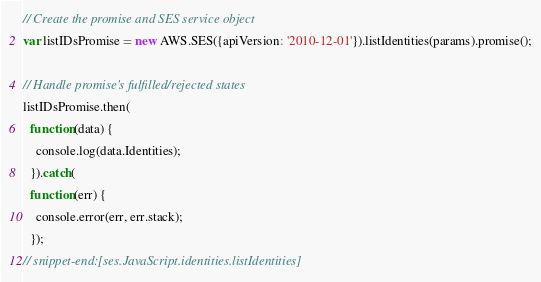<code> <loc_0><loc_0><loc_500><loc_500><_JavaScript_>
// Create the promise and SES service object
var listIDsPromise = new AWS.SES({apiVersion: '2010-12-01'}).listIdentities(params).promise();

// Handle promise's fulfilled/rejected states
listIDsPromise.then(
  function(data) {
    console.log(data.Identities);
  }).catch(
  function(err) {
    console.error(err, err.stack);
  });
// snippet-end:[ses.JavaScript.identities.listIdentities]
</code> 